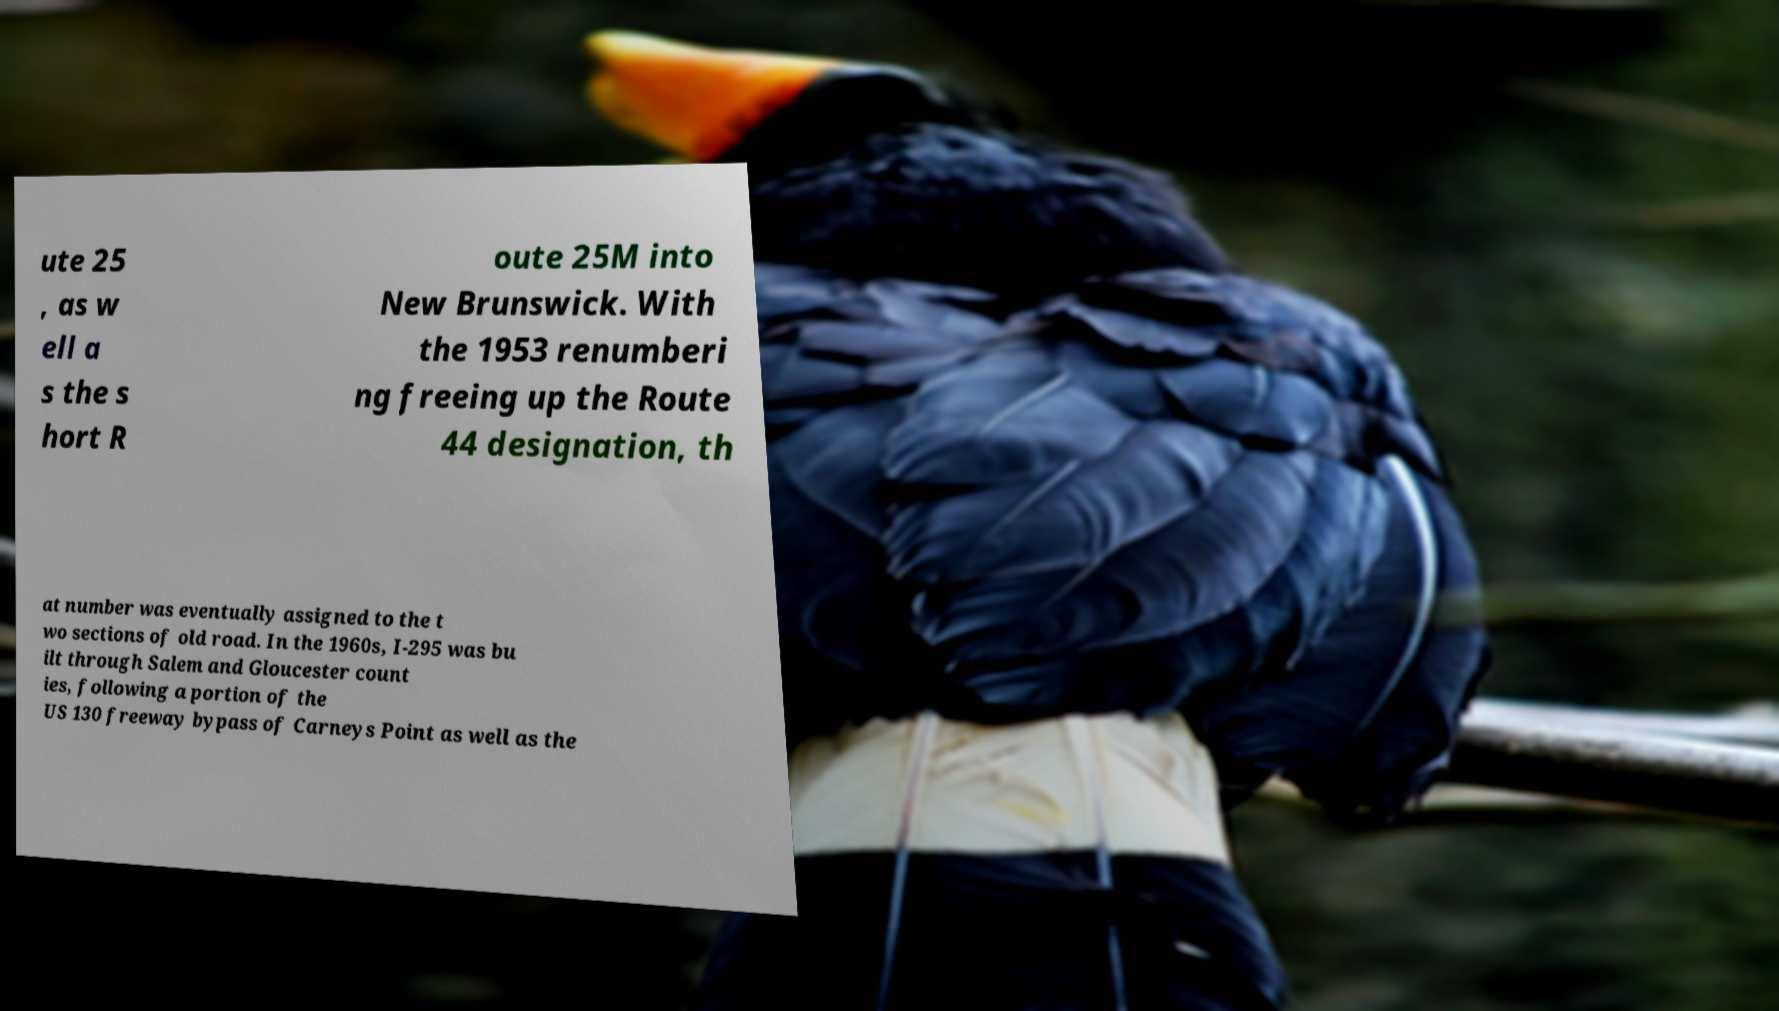Could you extract and type out the text from this image? ute 25 , as w ell a s the s hort R oute 25M into New Brunswick. With the 1953 renumberi ng freeing up the Route 44 designation, th at number was eventually assigned to the t wo sections of old road. In the 1960s, I-295 was bu ilt through Salem and Gloucester count ies, following a portion of the US 130 freeway bypass of Carneys Point as well as the 